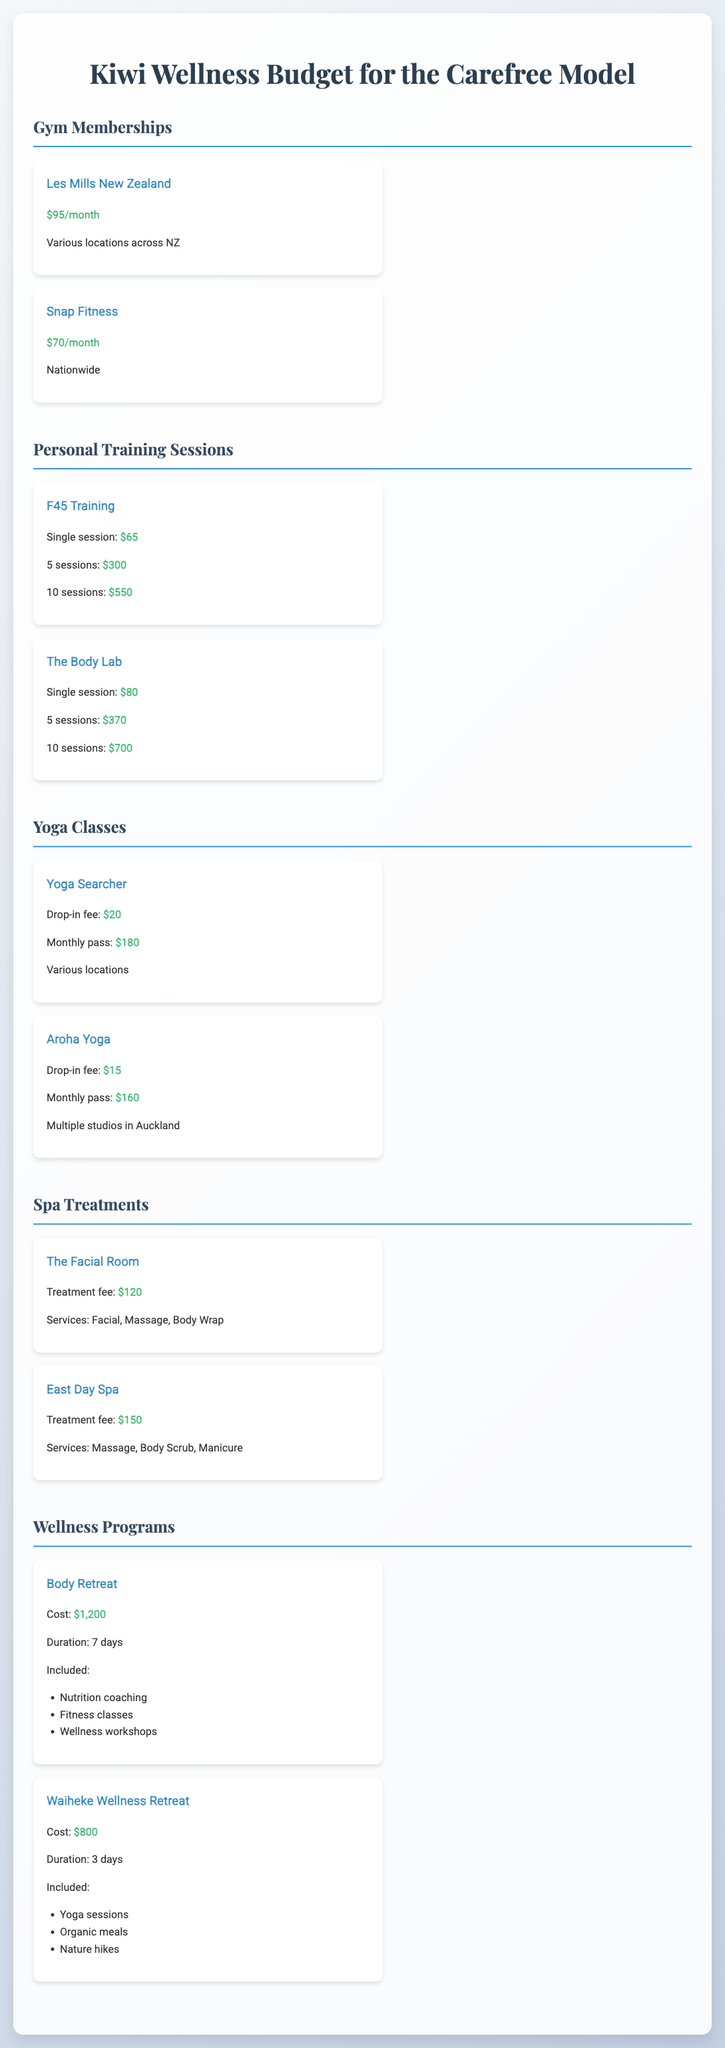What is the monthly cost of Les Mills New Zealand? The monthly cost of Les Mills New Zealand as stated in the document is $95.
Answer: $95 How much do 10 personal training sessions at F45 Training cost? According to the document, 10 personal training sessions at F45 Training cost $550.
Answer: $550 What is included in the Body Retreat? The Body Retreat includes Nutrition coaching, Fitness classes, and Wellness workshops.
Answer: Nutrition coaching, Fitness classes, Wellness workshops What is the monthly pass cost for Yoga Searcher? The monthly pass cost for Yoga Searcher is $180.
Answer: $180 How long is the Waiheke Wellness Retreat? The duration of the Waiheke Wellness Retreat is 3 days.
Answer: 3 days What is the treatment fee for The Facial Room? The treatment fee for The Facial Room is $120.
Answer: $120 What is the total cost for 5 sessions at The Body Lab? The total cost for 5 sessions at The Body Lab is $370, as per the document.
Answer: $370 What services does East Day Spa offer? East Day Spa offers Massage, Body Scrub, and Manicure services.
Answer: Massage, Body Scrub, Manicure How much does a drop-in fee at Aroha Yoga cost? The drop-in fee at Aroha Yoga costs $15.
Answer: $15 